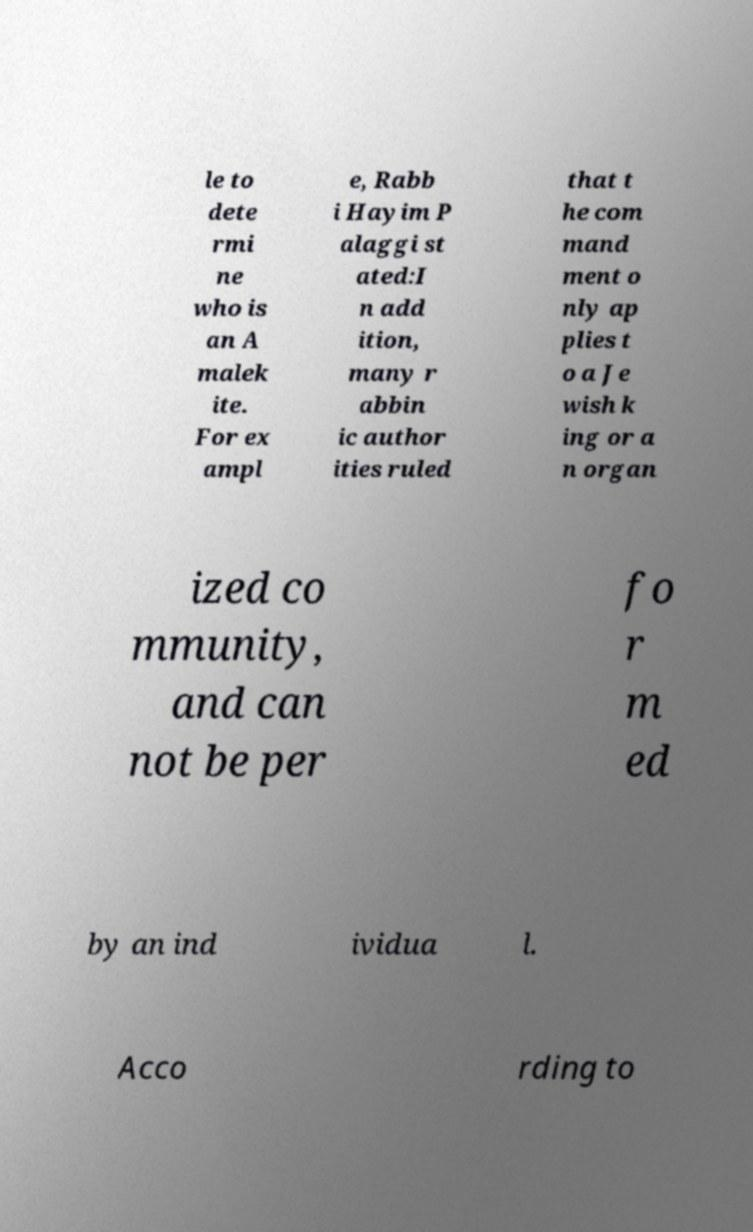Can you read and provide the text displayed in the image?This photo seems to have some interesting text. Can you extract and type it out for me? le to dete rmi ne who is an A malek ite. For ex ampl e, Rabb i Hayim P alaggi st ated:I n add ition, many r abbin ic author ities ruled that t he com mand ment o nly ap plies t o a Je wish k ing or a n organ ized co mmunity, and can not be per fo r m ed by an ind ividua l. Acco rding to 